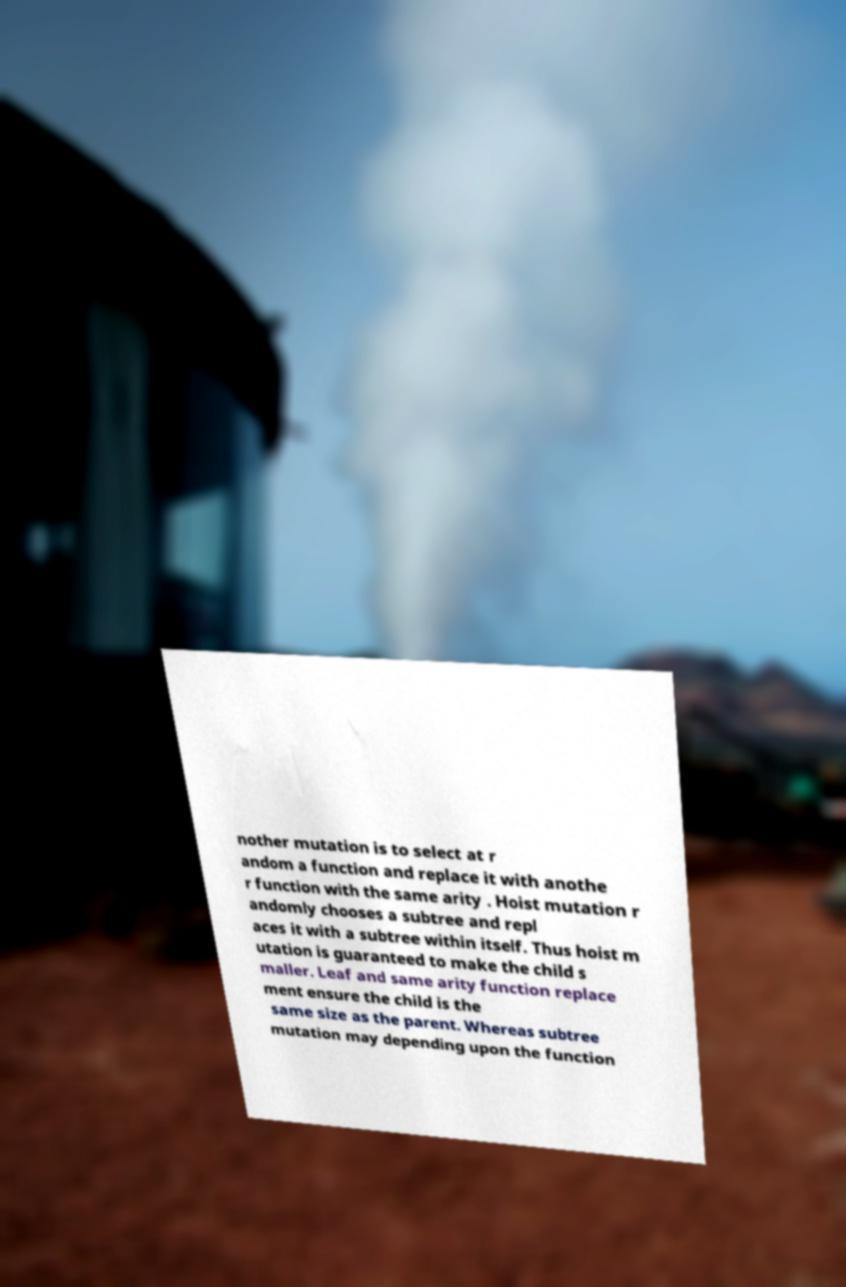Could you extract and type out the text from this image? nother mutation is to select at r andom a function and replace it with anothe r function with the same arity . Hoist mutation r andomly chooses a subtree and repl aces it with a subtree within itself. Thus hoist m utation is guaranteed to make the child s maller. Leaf and same arity function replace ment ensure the child is the same size as the parent. Whereas subtree mutation may depending upon the function 